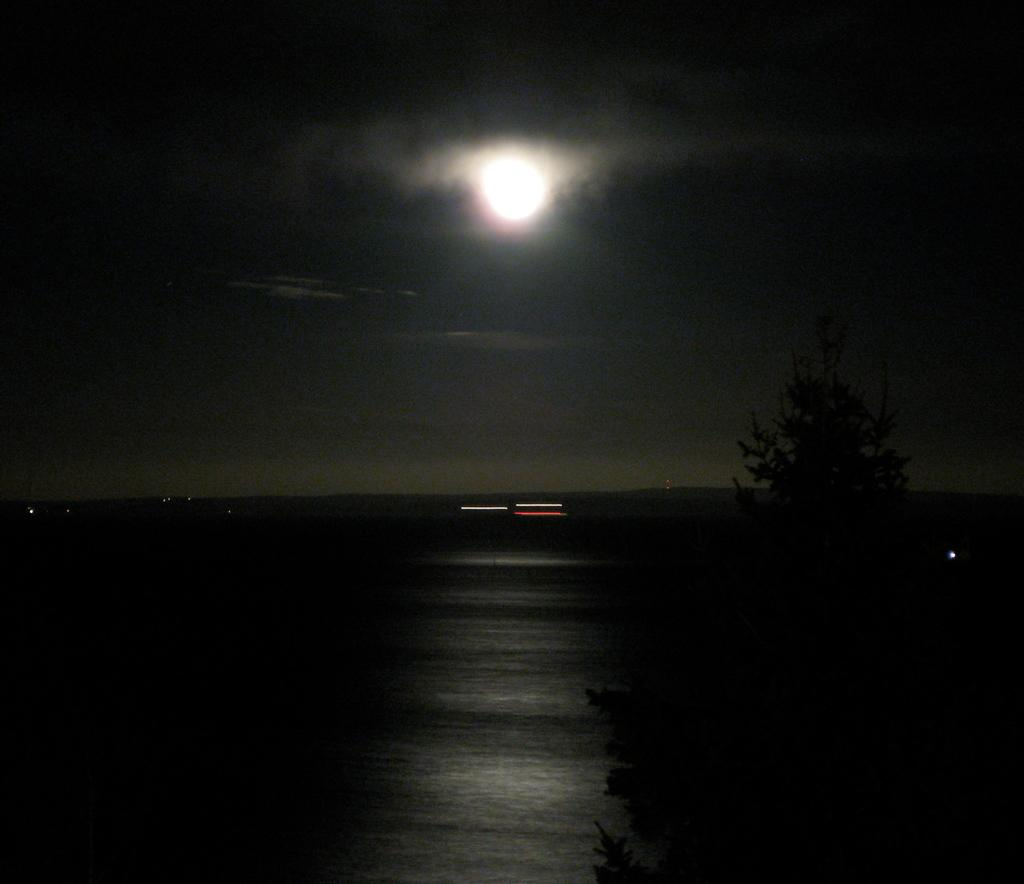What is the overall lighting condition in the image? The image is dark. What type of natural elements can be seen in the image? There are trees in the image. Are there any artificial light sources visible in the image? Yes, there are lights in the image. What celestial body is visible in the sky in the image? The moon is visible in the sky. What type of pies are being served at the picnic in the image? There is no picnic or pies present in the image; it features a dark scene with trees, lights, and the moon. What gardening tool is being used to dig in the garden in the image? There is no gardening tool or garden present in the image. 